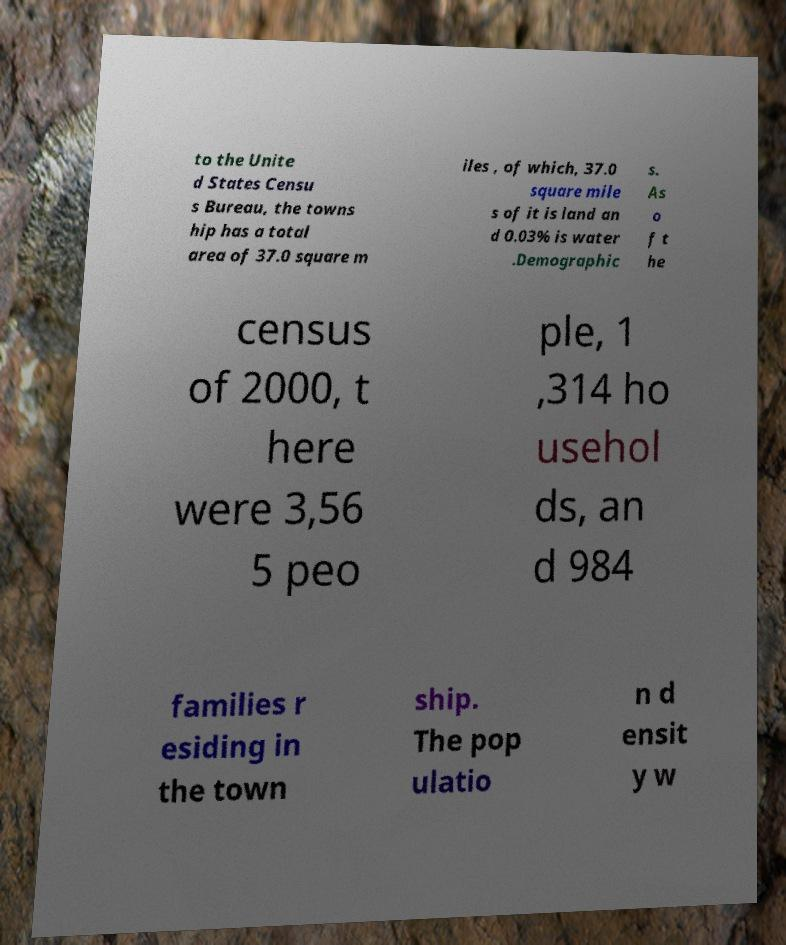I need the written content from this picture converted into text. Can you do that? to the Unite d States Censu s Bureau, the towns hip has a total area of 37.0 square m iles , of which, 37.0 square mile s of it is land an d 0.03% is water .Demographic s. As o f t he census of 2000, t here were 3,56 5 peo ple, 1 ,314 ho usehol ds, an d 984 families r esiding in the town ship. The pop ulatio n d ensit y w 